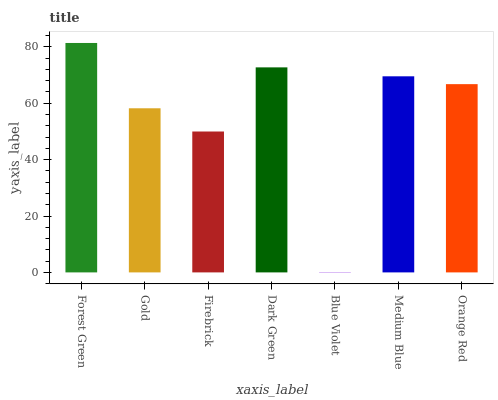Is Blue Violet the minimum?
Answer yes or no. Yes. Is Forest Green the maximum?
Answer yes or no. Yes. Is Gold the minimum?
Answer yes or no. No. Is Gold the maximum?
Answer yes or no. No. Is Forest Green greater than Gold?
Answer yes or no. Yes. Is Gold less than Forest Green?
Answer yes or no. Yes. Is Gold greater than Forest Green?
Answer yes or no. No. Is Forest Green less than Gold?
Answer yes or no. No. Is Orange Red the high median?
Answer yes or no. Yes. Is Orange Red the low median?
Answer yes or no. Yes. Is Gold the high median?
Answer yes or no. No. Is Dark Green the low median?
Answer yes or no. No. 